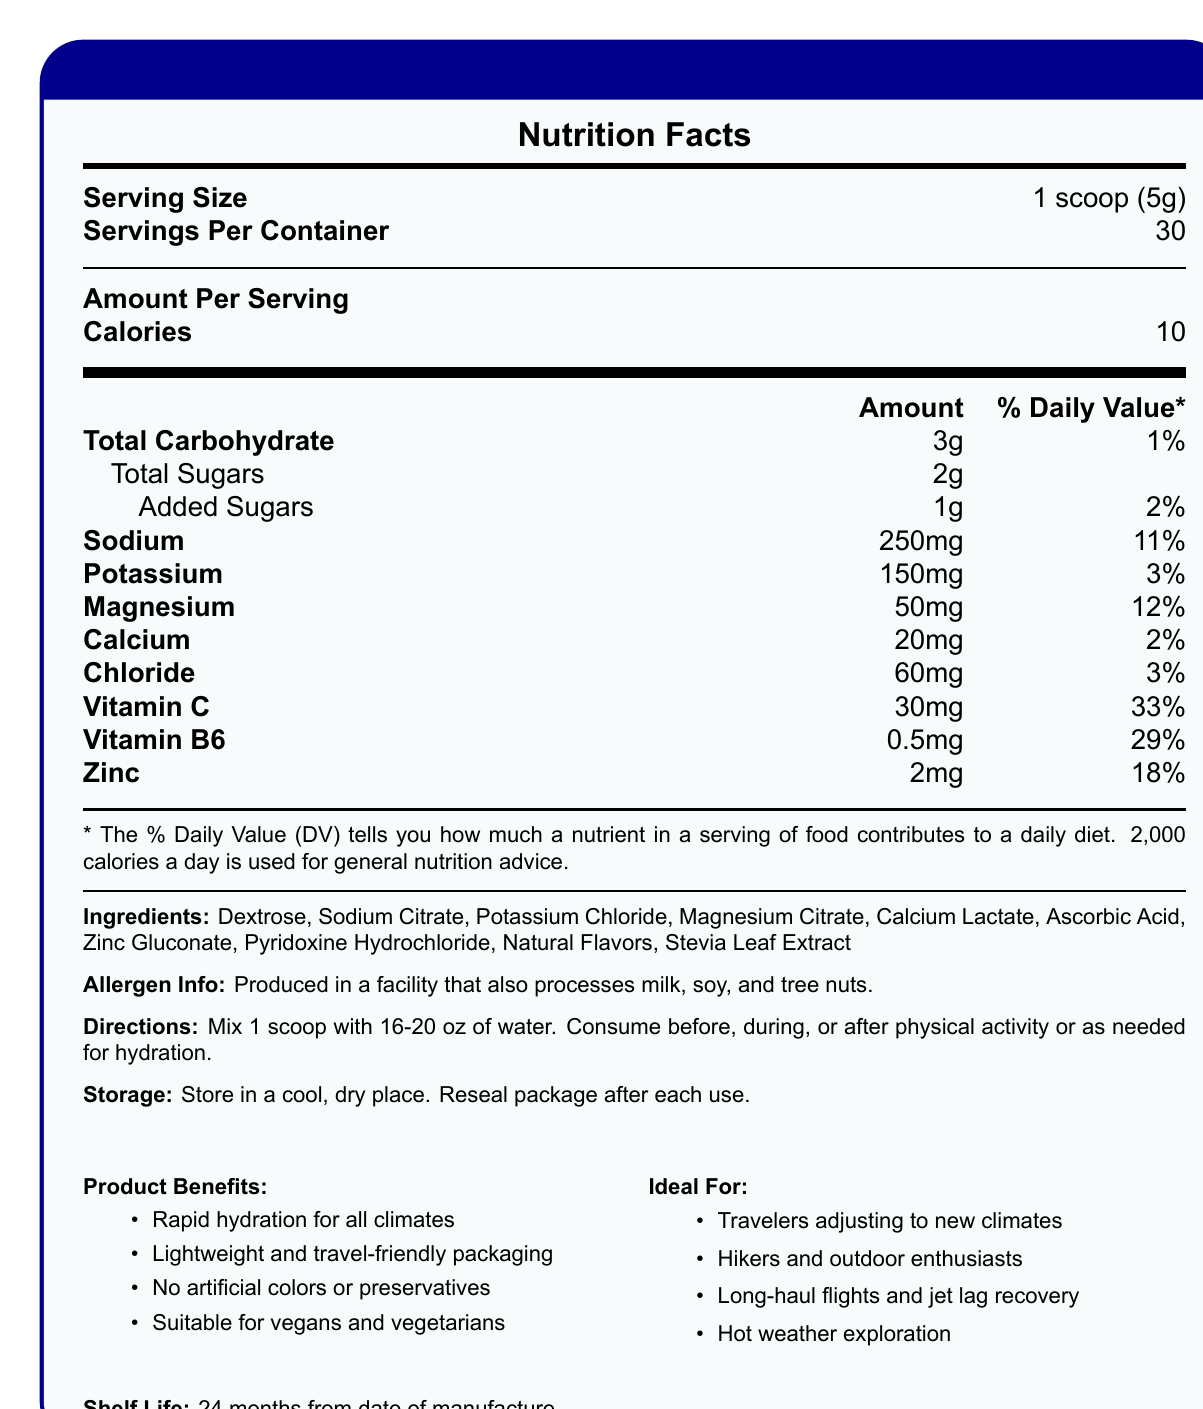what is the serving size? The document lists the serving size as 1 scoop, which is equivalent to 5 grams.
Answer: 1 scoop (5g) how many servings are in the container? According to the document, the number of servings per container is 30.
Answer: 30 how many calories are in one serving? The document states that each serving contains 10 calories.
Answer: 10 how much sodium is in one serving? The document specifies that there are 250mg of sodium per serving.
Answer: 250mg what percentage of the daily value of magnesium does one serving provide? One serving provides 12% of the daily value for magnesium as indicated in the document.
Answer: 12% what is the total carbohydrate content in one serving? A. 2g B. 3g C. 5g D. 10g The document shows that there are 3 grams of total carbohydrates in one serving.
Answer: B what is the daily value percentage for zinc in one serving? A. 18% B. 29% C. 33% D. 3% The daily value percentage for zinc in one serving is 18%, as mentioned in the document.
Answer: A is the product suitable for vegans and vegetarians? The document states that the product is suitable for vegans and vegetarians.
Answer: Yes does the product contain any artificial colors or preservatives? The document mentions that the product has no artificial colors or preservatives.
Answer: No summarize the main idea of the document The document provides detailed nutritional information about TravelLyte Ultra Hydration Powder, highlighting its benefits for travelers and active individuals, its suitability for vegans and vegetarians, and its free-from artificial colors and preservatives.
Answer: TravelLyte Ultra Hydration Powder offers a rapid hydration solution for travelers and outdoor enthusiasts. Each serving provides essential electrolytes and vitamins, with specific nutritional information listed. The product is lightweight, travel-friendly, and free from artificial colors and preservatives. It is suitable for vegans and vegetarians. what health benefits does vitamin C in the product provide? The document does not detail the specific health benefits provided by vitamin C; it only lists the amount and daily value percentage.
Answer: Not enough information what should you do after consuming the product? The document provides detailed directions on how to consume the product but does not specify actions to take after consuming it.
Answer: I don't know what are the primary ingredients in the hydration powder? The document lists these as the primary ingredients in the hydration powder.
Answer: Dextrose, Sodium Citrate, Potassium Chloride, Magnesium Citrate, Calcium Lactate, Ascorbic Acid, Zinc Gluconate, Pyridoxine Hydrochloride, Natural Flavors, Stevia Leaf Extract what is the product primarily designed for? The document states that the product is ideal for these purposes.
Answer: Rapid hydration for all climates, travelers adjusting to new climates, hikers and outdoor enthusiasts, long-haul flights and jet lag recovery, hot weather exploration state the potential allergen information for this product The document specifies that the product is produced in a facility handling milk, soy, and tree nuts.
Answer: Produced in a facility that also processes milk, soy, and tree nuts. 